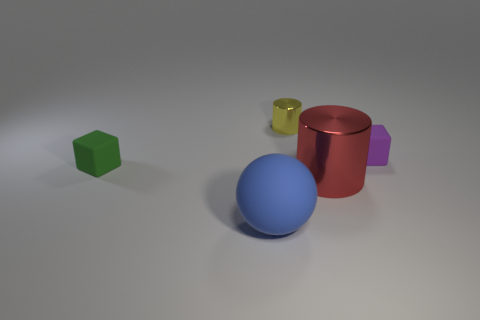Are there more metal cylinders on the left side of the small green rubber object than green matte things?
Offer a very short reply. No. What is the material of the blue sphere?
Make the answer very short. Rubber. What is the shape of the small object that is the same material as the big red object?
Your answer should be compact. Cylinder. There is a thing that is behind the cube on the right side of the red cylinder; what is its size?
Provide a short and direct response. Small. What is the color of the small metallic cylinder behind the tiny purple matte cube?
Offer a terse response. Yellow. Is there a big brown rubber thing of the same shape as the big red shiny object?
Make the answer very short. No. Is the number of large cylinders on the right side of the purple matte object less than the number of purple blocks in front of the small green thing?
Offer a terse response. No. What color is the small cylinder?
Provide a succinct answer. Yellow. Are there any small matte objects that are left of the metal object that is in front of the purple object?
Provide a succinct answer. Yes. How many blue balls have the same size as the purple object?
Keep it short and to the point. 0. 